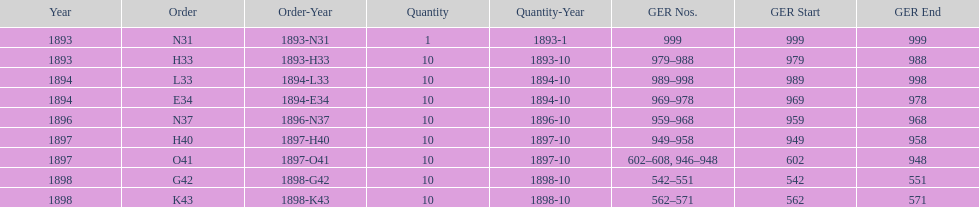Which year between 1893 and 1898 was there not an order? 1895. 